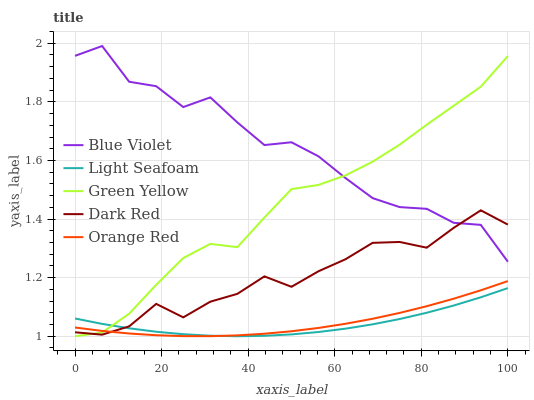Does Light Seafoam have the minimum area under the curve?
Answer yes or no. Yes. Does Blue Violet have the maximum area under the curve?
Answer yes or no. Yes. Does Green Yellow have the minimum area under the curve?
Answer yes or no. No. Does Green Yellow have the maximum area under the curve?
Answer yes or no. No. Is Orange Red the smoothest?
Answer yes or no. Yes. Is Blue Violet the roughest?
Answer yes or no. Yes. Is Green Yellow the smoothest?
Answer yes or no. No. Is Green Yellow the roughest?
Answer yes or no. No. Does Green Yellow have the lowest value?
Answer yes or no. Yes. Does Light Seafoam have the lowest value?
Answer yes or no. No. Does Blue Violet have the highest value?
Answer yes or no. Yes. Does Green Yellow have the highest value?
Answer yes or no. No. Is Light Seafoam less than Blue Violet?
Answer yes or no. Yes. Is Blue Violet greater than Light Seafoam?
Answer yes or no. Yes. Does Dark Red intersect Green Yellow?
Answer yes or no. Yes. Is Dark Red less than Green Yellow?
Answer yes or no. No. Is Dark Red greater than Green Yellow?
Answer yes or no. No. Does Light Seafoam intersect Blue Violet?
Answer yes or no. No. 